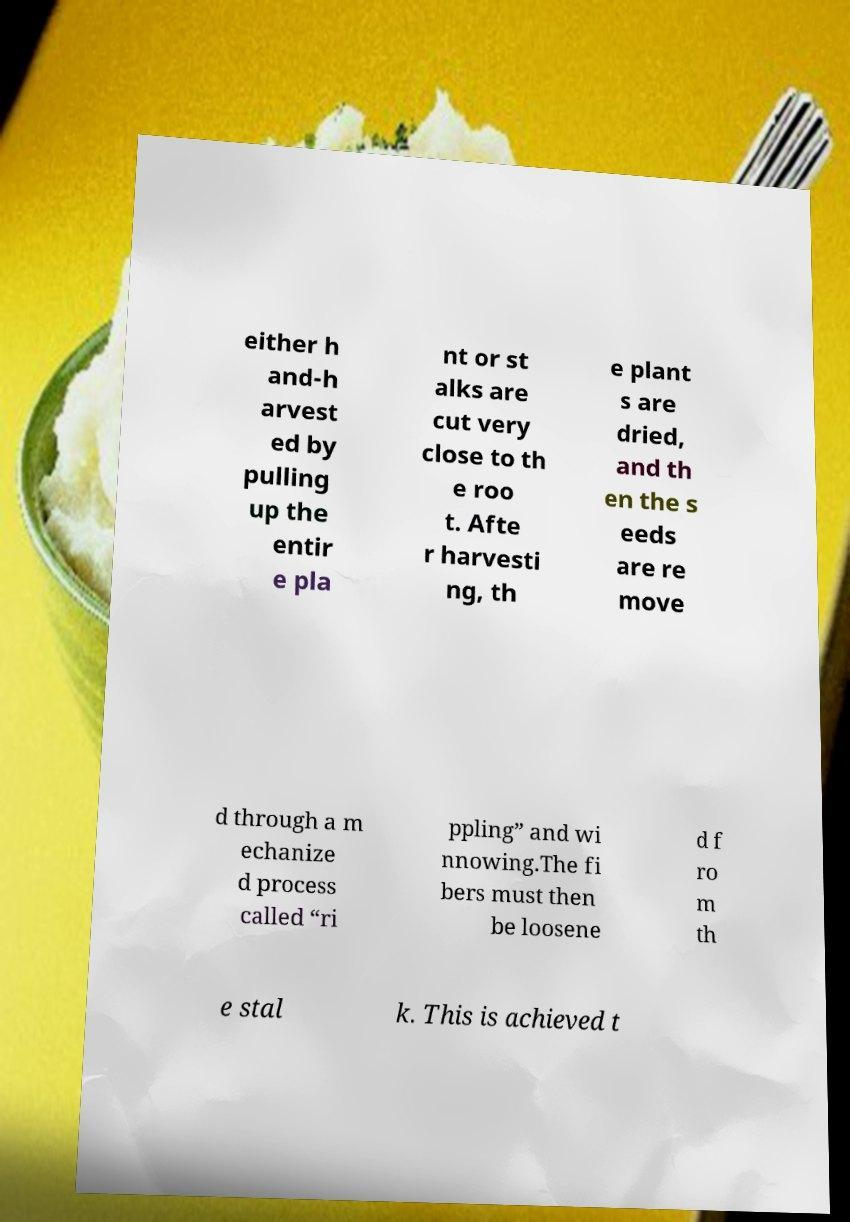Can you read and provide the text displayed in the image?This photo seems to have some interesting text. Can you extract and type it out for me? either h and-h arvest ed by pulling up the entir e pla nt or st alks are cut very close to th e roo t. Afte r harvesti ng, th e plant s are dried, and th en the s eeds are re move d through a m echanize d process called “ri ppling” and wi nnowing.The fi bers must then be loosene d f ro m th e stal k. This is achieved t 